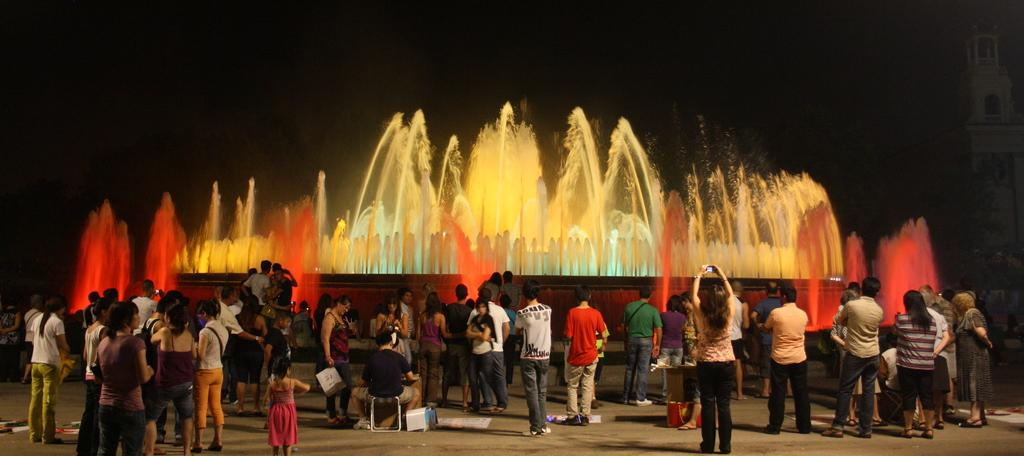How many people are in the image? There are many people in the image. Where are the people located in the image? The people are standing in the front. What natural feature can be seen in the image? There is a waterfall in the image. What is unique about the waterfall? The waterfall has colorful lights on it. What is the color of the background in the image? The background of the image is dark. What type of store can be seen in the image? There is no store present in the image; it features people standing in front of a waterfall with colorful lights. What kind of pain is the person in the image experiencing? There is no indication of pain or any person experiencing pain in the image. 